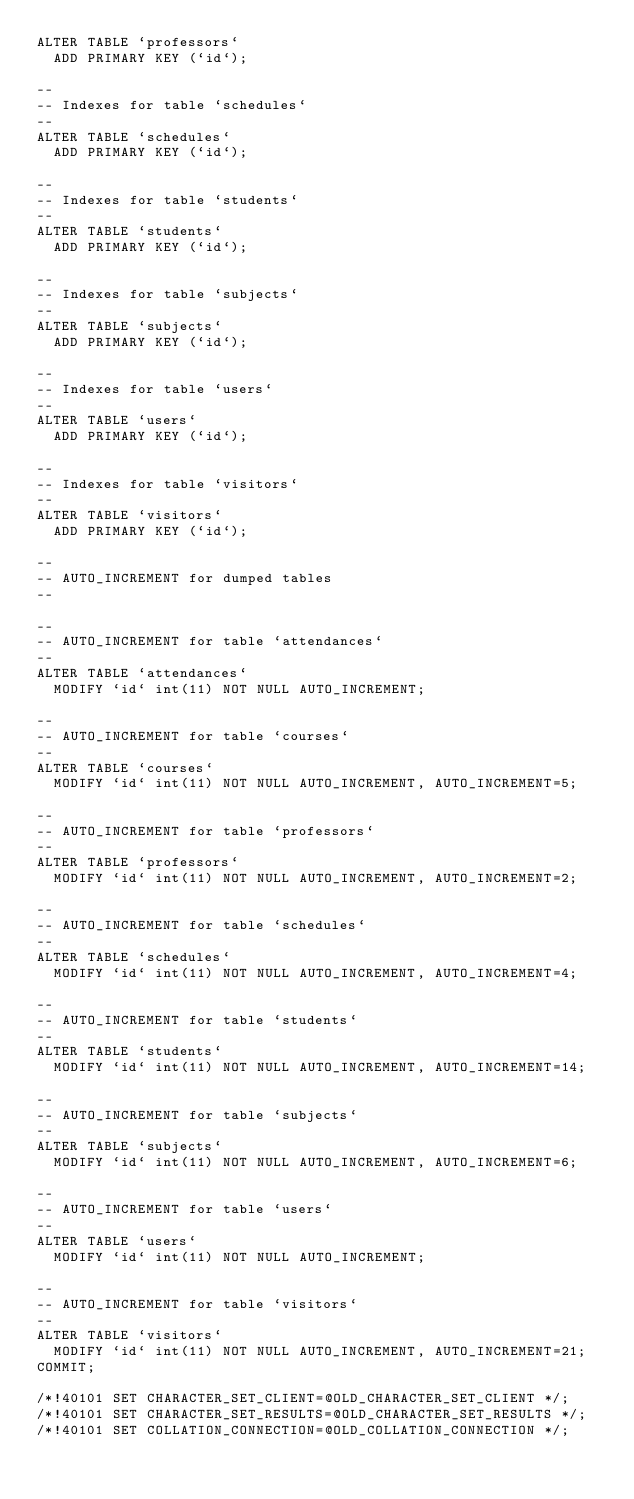Convert code to text. <code><loc_0><loc_0><loc_500><loc_500><_SQL_>ALTER TABLE `professors`
  ADD PRIMARY KEY (`id`);

--
-- Indexes for table `schedules`
--
ALTER TABLE `schedules`
  ADD PRIMARY KEY (`id`);

--
-- Indexes for table `students`
--
ALTER TABLE `students`
  ADD PRIMARY KEY (`id`);

--
-- Indexes for table `subjects`
--
ALTER TABLE `subjects`
  ADD PRIMARY KEY (`id`);

--
-- Indexes for table `users`
--
ALTER TABLE `users`
  ADD PRIMARY KEY (`id`);

--
-- Indexes for table `visitors`
--
ALTER TABLE `visitors`
  ADD PRIMARY KEY (`id`);

--
-- AUTO_INCREMENT for dumped tables
--

--
-- AUTO_INCREMENT for table `attendances`
--
ALTER TABLE `attendances`
  MODIFY `id` int(11) NOT NULL AUTO_INCREMENT;

--
-- AUTO_INCREMENT for table `courses`
--
ALTER TABLE `courses`
  MODIFY `id` int(11) NOT NULL AUTO_INCREMENT, AUTO_INCREMENT=5;

--
-- AUTO_INCREMENT for table `professors`
--
ALTER TABLE `professors`
  MODIFY `id` int(11) NOT NULL AUTO_INCREMENT, AUTO_INCREMENT=2;

--
-- AUTO_INCREMENT for table `schedules`
--
ALTER TABLE `schedules`
  MODIFY `id` int(11) NOT NULL AUTO_INCREMENT, AUTO_INCREMENT=4;

--
-- AUTO_INCREMENT for table `students`
--
ALTER TABLE `students`
  MODIFY `id` int(11) NOT NULL AUTO_INCREMENT, AUTO_INCREMENT=14;

--
-- AUTO_INCREMENT for table `subjects`
--
ALTER TABLE `subjects`
  MODIFY `id` int(11) NOT NULL AUTO_INCREMENT, AUTO_INCREMENT=6;

--
-- AUTO_INCREMENT for table `users`
--
ALTER TABLE `users`
  MODIFY `id` int(11) NOT NULL AUTO_INCREMENT;

--
-- AUTO_INCREMENT for table `visitors`
--
ALTER TABLE `visitors`
  MODIFY `id` int(11) NOT NULL AUTO_INCREMENT, AUTO_INCREMENT=21;
COMMIT;

/*!40101 SET CHARACTER_SET_CLIENT=@OLD_CHARACTER_SET_CLIENT */;
/*!40101 SET CHARACTER_SET_RESULTS=@OLD_CHARACTER_SET_RESULTS */;
/*!40101 SET COLLATION_CONNECTION=@OLD_COLLATION_CONNECTION */;
</code> 